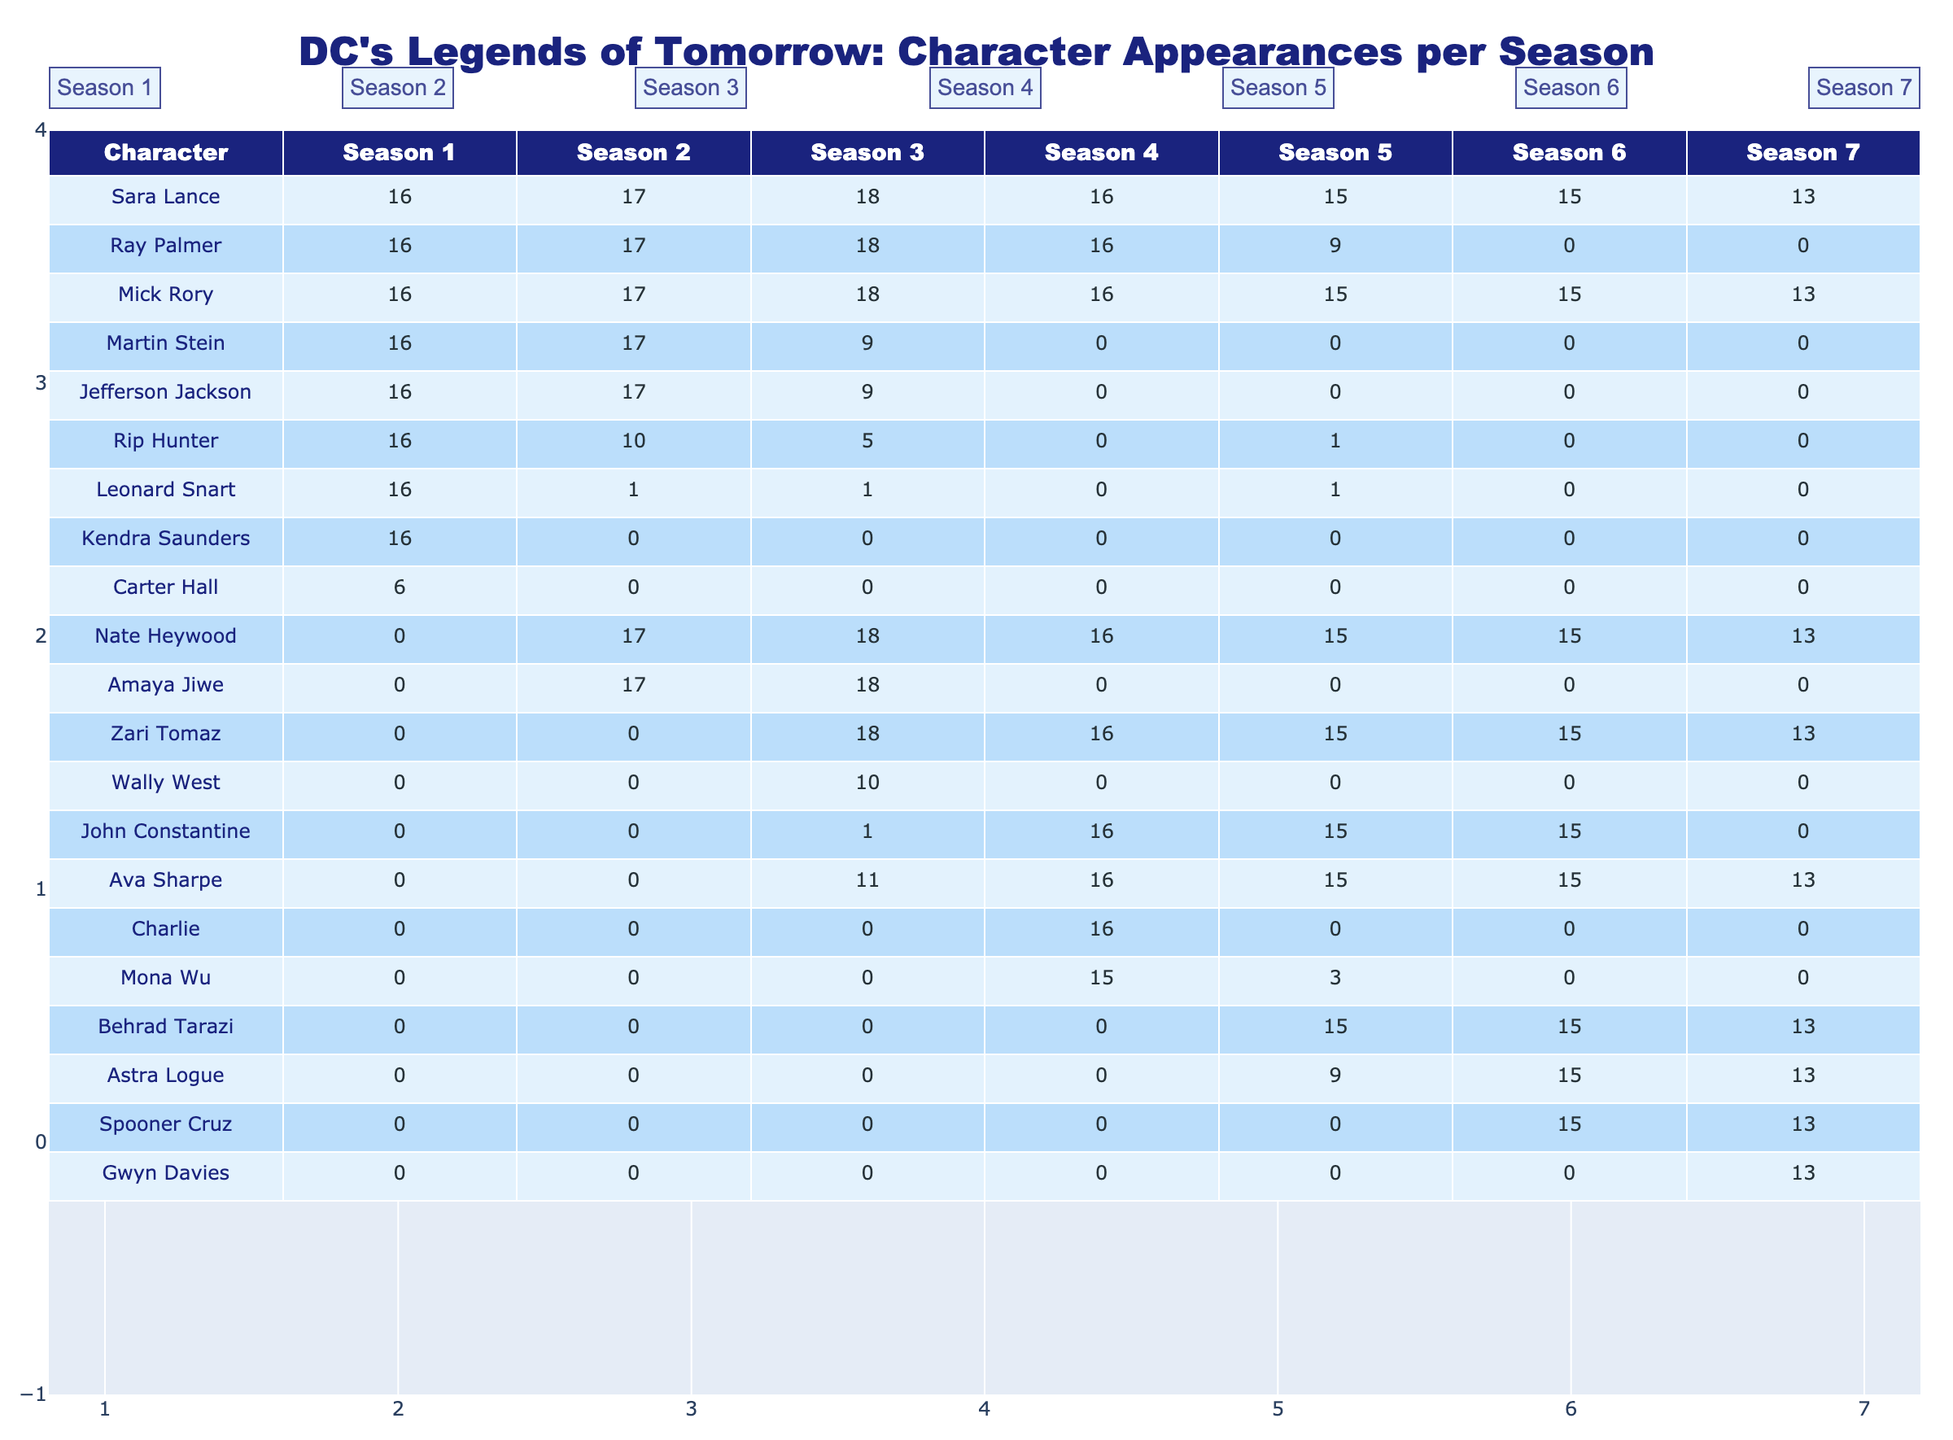What character appeared the most in Season 1? By reviewing the data in Season 1, we can see that Sara Lance, Ray Palmer, Mick Rory, Martin Stein, Jefferson Jackson, Leonard Snart, and Kendra Saunders each appeared 16 times, which is the maximum. However, Sara Lance is often considered the main protagonist, making her the standout character.
Answer: Sara Lance What is the total number of appearances for Nate Heywood across all seasons? Adding Nate Heywood's appearances from each season: 0 + 17 + 18 + 16 + 15 + 15 + 13 = 84.
Answer: 84 Did John Constantine appear in Season 6? Looking at the data for John Constantine, it shows that he has 15 appearances in Season 6. Hence, the answer is yes.
Answer: Yes Which season had the least number of appearances for Martin Stein? Reviewing the data, Martin Stein had the least appearances in Season 4 with 0 appearances.
Answer: Season 4 Who had more appearances in Season 3, Amaya Jiwe or Wally West? Amaya Jiwe had 18 appearances in Season 3 while Wally West had 10 appearances. Thus, Amaya Jiwe had more appearances.
Answer: Amaya Jiwe What is the average number of appearances per season for Ray Palmer? Calculating Ray Palmer's appearances: (16 + 17 + 18 + 16 + 9 + 0 + 0) = 76. He appeared across 7 seasons, so the average is 76/7 ≈ 10.86.
Answer: 10.86 Which character appeared consistently across all seasons? Analyzing the data, Sara Lance, Mick Rory, and Nate Heywood were present in all seasons. Therefore, these characters can be considered as appearing consistently.
Answer: Sara Lance, Mick Rory, Nate Heywood What character had the highest number of appearances in Season 5? In Season 5, Behrad Tarazi had 15 appearances, which is the highest among all characters for that season.
Answer: Behrad Tarazi In how many total seasons did Leonard Snart appear? Leonard Snart appeared in 3 seasons: Season 1, Season 2, and Season 3.
Answer: 3 What is the difference in total appearances between Spooner Cruz and Gwyn Davies? Spooner Cruz has 13 appearances across Season 6 and 7, while Gwyn Davies has 13 appearances only in Season 7. Therefore, the difference is 13 - 13 = 0.
Answer: 0 